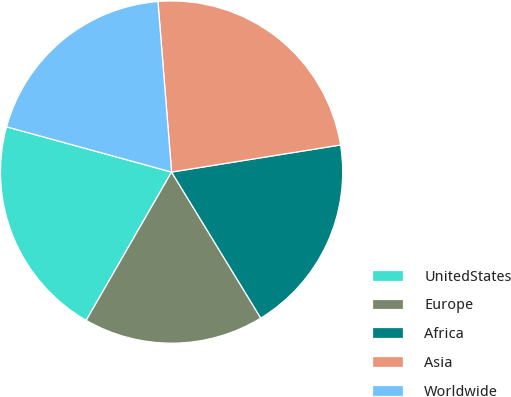<chart> <loc_0><loc_0><loc_500><loc_500><pie_chart><fcel>UnitedStates<fcel>Europe<fcel>Africa<fcel>Asia<fcel>Worldwide<nl><fcel>20.95%<fcel>17.04%<fcel>18.8%<fcel>23.74%<fcel>19.47%<nl></chart> 